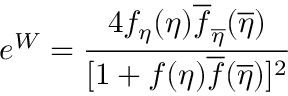<formula> <loc_0><loc_0><loc_500><loc_500>e ^ { W } = { \frac { 4 f _ { \eta } ( \eta ) \overline { f } _ { \overline { \eta } } ( \overline { \eta } ) } { [ 1 + f ( \eta ) \overline { f } ( \overline { \eta } ) ] ^ { 2 } } }</formula> 